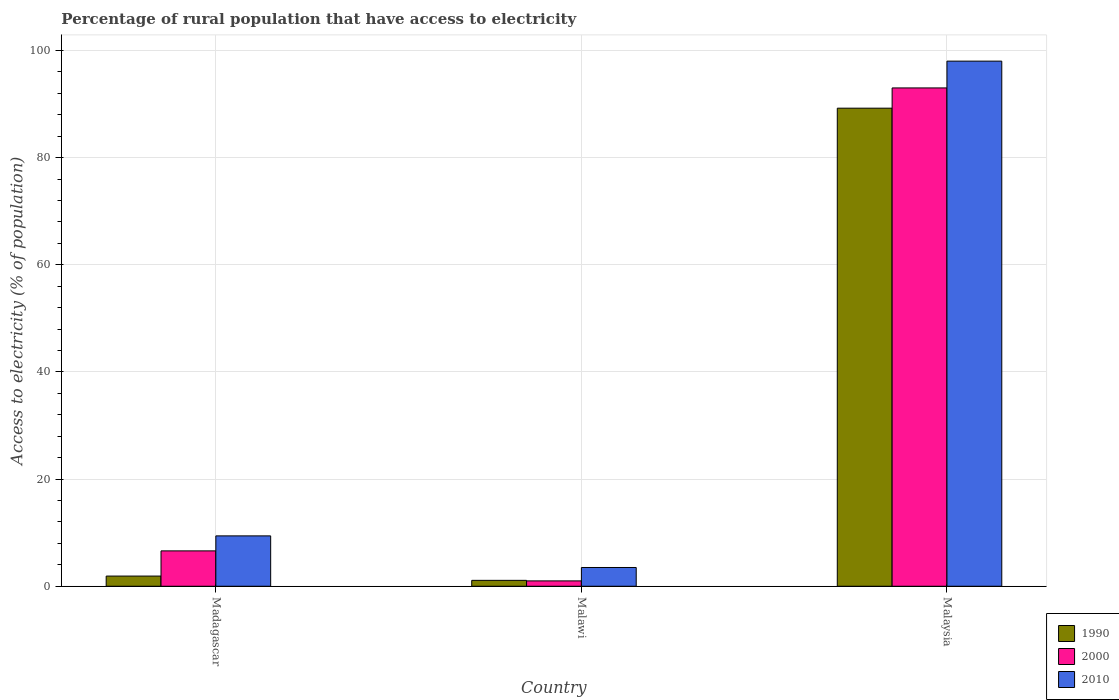How many different coloured bars are there?
Your answer should be compact. 3. Are the number of bars per tick equal to the number of legend labels?
Your response must be concise. Yes. What is the label of the 3rd group of bars from the left?
Ensure brevity in your answer.  Malaysia. In how many cases, is the number of bars for a given country not equal to the number of legend labels?
Provide a short and direct response. 0. What is the percentage of rural population that have access to electricity in 2010 in Malawi?
Keep it short and to the point. 3.5. Across all countries, what is the maximum percentage of rural population that have access to electricity in 1990?
Offer a very short reply. 89.22. In which country was the percentage of rural population that have access to electricity in 1990 maximum?
Your answer should be very brief. Malaysia. In which country was the percentage of rural population that have access to electricity in 2010 minimum?
Your response must be concise. Malawi. What is the total percentage of rural population that have access to electricity in 1990 in the graph?
Ensure brevity in your answer.  92.22. What is the difference between the percentage of rural population that have access to electricity in 1990 in Malawi and that in Malaysia?
Your response must be concise. -88.12. What is the difference between the percentage of rural population that have access to electricity in 1990 in Madagascar and the percentage of rural population that have access to electricity in 2000 in Malawi?
Your answer should be very brief. 0.9. What is the average percentage of rural population that have access to electricity in 2000 per country?
Make the answer very short. 33.53. What is the ratio of the percentage of rural population that have access to electricity in 1990 in Madagascar to that in Malawi?
Your response must be concise. 1.73. Is the percentage of rural population that have access to electricity in 2000 in Madagascar less than that in Malawi?
Your answer should be compact. No. What is the difference between the highest and the second highest percentage of rural population that have access to electricity in 2010?
Make the answer very short. -88.6. What is the difference between the highest and the lowest percentage of rural population that have access to electricity in 2000?
Provide a short and direct response. 92. In how many countries, is the percentage of rural population that have access to electricity in 2000 greater than the average percentage of rural population that have access to electricity in 2000 taken over all countries?
Give a very brief answer. 1. What does the 2nd bar from the right in Madagascar represents?
Keep it short and to the point. 2000. How many countries are there in the graph?
Make the answer very short. 3. Does the graph contain grids?
Offer a very short reply. Yes. Where does the legend appear in the graph?
Provide a succinct answer. Bottom right. What is the title of the graph?
Ensure brevity in your answer.  Percentage of rural population that have access to electricity. Does "2000" appear as one of the legend labels in the graph?
Give a very brief answer. Yes. What is the label or title of the Y-axis?
Provide a short and direct response. Access to electricity (% of population). What is the Access to electricity (% of population) in 2000 in Madagascar?
Your answer should be very brief. 6.6. What is the Access to electricity (% of population) of 2010 in Madagascar?
Give a very brief answer. 9.4. What is the Access to electricity (% of population) in 1990 in Malaysia?
Offer a terse response. 89.22. What is the Access to electricity (% of population) in 2000 in Malaysia?
Your response must be concise. 93. What is the Access to electricity (% of population) of 2010 in Malaysia?
Your response must be concise. 98. Across all countries, what is the maximum Access to electricity (% of population) in 1990?
Ensure brevity in your answer.  89.22. Across all countries, what is the maximum Access to electricity (% of population) of 2000?
Your answer should be compact. 93. Across all countries, what is the maximum Access to electricity (% of population) in 2010?
Give a very brief answer. 98. Across all countries, what is the minimum Access to electricity (% of population) of 2000?
Offer a terse response. 1. Across all countries, what is the minimum Access to electricity (% of population) in 2010?
Your answer should be compact. 3.5. What is the total Access to electricity (% of population) in 1990 in the graph?
Your answer should be compact. 92.22. What is the total Access to electricity (% of population) of 2000 in the graph?
Provide a succinct answer. 100.6. What is the total Access to electricity (% of population) in 2010 in the graph?
Your answer should be compact. 110.9. What is the difference between the Access to electricity (% of population) of 1990 in Madagascar and that in Malaysia?
Your response must be concise. -87.32. What is the difference between the Access to electricity (% of population) in 2000 in Madagascar and that in Malaysia?
Your response must be concise. -86.4. What is the difference between the Access to electricity (% of population) of 2010 in Madagascar and that in Malaysia?
Your answer should be very brief. -88.6. What is the difference between the Access to electricity (% of population) of 1990 in Malawi and that in Malaysia?
Keep it short and to the point. -88.12. What is the difference between the Access to electricity (% of population) in 2000 in Malawi and that in Malaysia?
Ensure brevity in your answer.  -92. What is the difference between the Access to electricity (% of population) in 2010 in Malawi and that in Malaysia?
Provide a short and direct response. -94.5. What is the difference between the Access to electricity (% of population) in 1990 in Madagascar and the Access to electricity (% of population) in 2000 in Malawi?
Provide a succinct answer. 0.9. What is the difference between the Access to electricity (% of population) of 2000 in Madagascar and the Access to electricity (% of population) of 2010 in Malawi?
Provide a short and direct response. 3.1. What is the difference between the Access to electricity (% of population) of 1990 in Madagascar and the Access to electricity (% of population) of 2000 in Malaysia?
Give a very brief answer. -91.1. What is the difference between the Access to electricity (% of population) in 1990 in Madagascar and the Access to electricity (% of population) in 2010 in Malaysia?
Offer a very short reply. -96.1. What is the difference between the Access to electricity (% of population) in 2000 in Madagascar and the Access to electricity (% of population) in 2010 in Malaysia?
Keep it short and to the point. -91.4. What is the difference between the Access to electricity (% of population) of 1990 in Malawi and the Access to electricity (% of population) of 2000 in Malaysia?
Ensure brevity in your answer.  -91.9. What is the difference between the Access to electricity (% of population) in 1990 in Malawi and the Access to electricity (% of population) in 2010 in Malaysia?
Ensure brevity in your answer.  -96.9. What is the difference between the Access to electricity (% of population) of 2000 in Malawi and the Access to electricity (% of population) of 2010 in Malaysia?
Offer a very short reply. -97. What is the average Access to electricity (% of population) of 1990 per country?
Make the answer very short. 30.74. What is the average Access to electricity (% of population) of 2000 per country?
Offer a very short reply. 33.53. What is the average Access to electricity (% of population) of 2010 per country?
Your answer should be compact. 36.97. What is the difference between the Access to electricity (% of population) of 1990 and Access to electricity (% of population) of 2000 in Madagascar?
Your answer should be compact. -4.7. What is the difference between the Access to electricity (% of population) in 2000 and Access to electricity (% of population) in 2010 in Madagascar?
Your answer should be very brief. -2.8. What is the difference between the Access to electricity (% of population) of 1990 and Access to electricity (% of population) of 2010 in Malawi?
Make the answer very short. -2.4. What is the difference between the Access to electricity (% of population) of 1990 and Access to electricity (% of population) of 2000 in Malaysia?
Provide a succinct answer. -3.78. What is the difference between the Access to electricity (% of population) in 1990 and Access to electricity (% of population) in 2010 in Malaysia?
Provide a short and direct response. -8.78. What is the ratio of the Access to electricity (% of population) in 1990 in Madagascar to that in Malawi?
Your answer should be compact. 1.73. What is the ratio of the Access to electricity (% of population) in 2000 in Madagascar to that in Malawi?
Provide a short and direct response. 6.6. What is the ratio of the Access to electricity (% of population) in 2010 in Madagascar to that in Malawi?
Your answer should be compact. 2.69. What is the ratio of the Access to electricity (% of population) in 1990 in Madagascar to that in Malaysia?
Provide a short and direct response. 0.02. What is the ratio of the Access to electricity (% of population) of 2000 in Madagascar to that in Malaysia?
Ensure brevity in your answer.  0.07. What is the ratio of the Access to electricity (% of population) of 2010 in Madagascar to that in Malaysia?
Your response must be concise. 0.1. What is the ratio of the Access to electricity (% of population) in 1990 in Malawi to that in Malaysia?
Your answer should be very brief. 0.01. What is the ratio of the Access to electricity (% of population) of 2000 in Malawi to that in Malaysia?
Ensure brevity in your answer.  0.01. What is the ratio of the Access to electricity (% of population) of 2010 in Malawi to that in Malaysia?
Give a very brief answer. 0.04. What is the difference between the highest and the second highest Access to electricity (% of population) of 1990?
Your answer should be very brief. 87.32. What is the difference between the highest and the second highest Access to electricity (% of population) of 2000?
Provide a succinct answer. 86.4. What is the difference between the highest and the second highest Access to electricity (% of population) in 2010?
Provide a short and direct response. 88.6. What is the difference between the highest and the lowest Access to electricity (% of population) of 1990?
Keep it short and to the point. 88.12. What is the difference between the highest and the lowest Access to electricity (% of population) of 2000?
Offer a terse response. 92. What is the difference between the highest and the lowest Access to electricity (% of population) in 2010?
Offer a terse response. 94.5. 